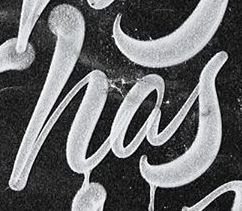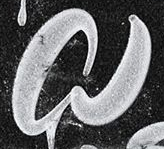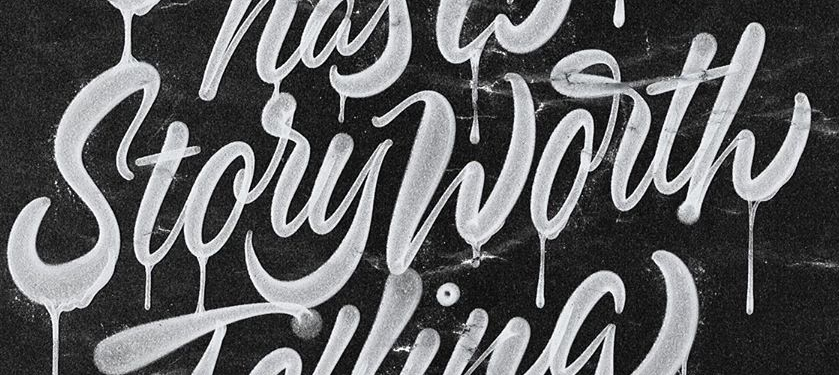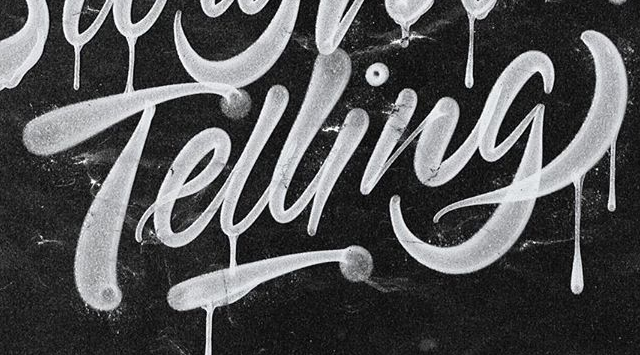Read the text content from these images in order, separated by a semicolon. has; a; StoryWorth; Telling 